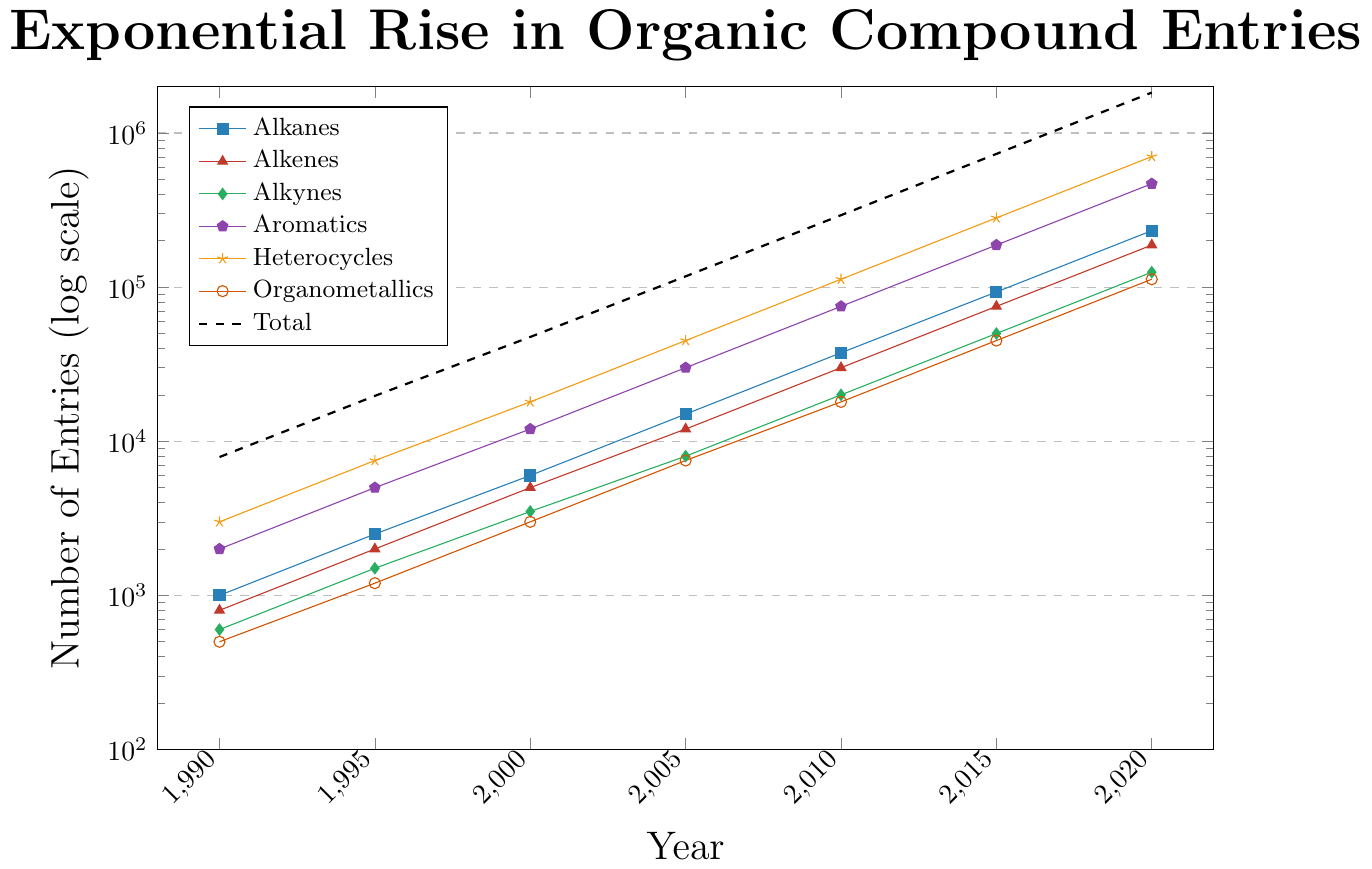What's the largest structural class of organic compounds recorded in 2020? First, look at the y-axis to see which compound class has the highest number in 2020. Among the alkanes, alkenes, alkynes, aromatics, heterocycles, and organometallics, identify the one with the maximum value. The dashed black line indicates the total, which isn't a structural class. In 2020, Heterocycles have the highest value.
Answer: Heterocycles How has the number of aromatic compounds changed from 1990 to 2020? To determine this, we need to look at the data points for aromatics in 1990 and 2020. In 1990, the number of aromatic entries is 2000. In 2020, it's 468750. Subtract the 1990 value from the 2020 value to find the difference: 468750 - 2000 = 466750.
Answer: Increased by 466750 Which structural class saw the fastest growth rate between 1990 and 2020? The growth rate can be estimated by comparing the ratio of the number of entries in 2020 to those in 1990 for each class. For alkanes: (232500/1000 = 232.5), alkenes: (187500/800 = 234.375), alkynes: (125000/600 = 208.33), aromatics: (468750/2000 = 234.375), heterocycles: (703125/3000 = 234.38), organometallics: (112500/500 = 225). Heterocycles have the highest ratio.
Answer: Heterocycles What is the trend in the total number of organic compound entries from 1990 to 2020? By observing the dashed black line that represents the total number of entries, it is clear that the entries increase exponentially from 1990 to 2020.
Answer: Exponential increase Which year saw the largest increase in the number of alkene entries compared to the previous recorded year? We need to calculate the difference in alkene entries between each adjacent pair of years. The differences are: 1995-1990: 2000-800 = 1200, 2000-1995: 5000-2000 = 3000, 2005-2000: 12000-5000 = 7000, 2010-2005: 30000-12000 = 18000, 2015-2010: 75000-30000 = 45000, 2020-2015: 187500-75000 = 112500. The largest increase is from 2015 to 2020.
Answer: 2020 How does the number of organometallic entries in 2020 compare with the number of alkane entries in 2015? Looking at the organometallic data for 2020, we see 112500 entries. For alkanes in 2015, there are 93000 entries. 112500 for organometallics in 2020 is greater than 93000 for alkanes in 2015.
Answer: Organometallics in 2020 are more than alkanes in 2015 What is the proportional gain of alkynes from 1995 to 2000? The number of alkynes in 1995 is 1500. In 2000, it is 3500. Compute the proportional gain by using the formula: (3500 - 1500) / 1500. The gain is (2000 / 1500) = 1.33, which indicates a 133% increase.
Answer: 133% Which structural class's entries reached 50000 first, and in which year? We need to identify the class that first reached the 50000 entries mark. From the graph, alkynes reach 50000 in 2015, while heterocycles reach it in the same year but with a higher count. However, aromatics touch 50000 earlier in 2010.
Answer: Aromatics in 2010 By what factor did the total number of organic compounds increase from 1990 to 2020? The total number of entries in 1990 is 7900. In 2020, it is 1829375. Compute the factor by dividing the 2020 value by the 1990 value: 1829375 / 7900 ≠ 231.10.
Answer: By about 231-fold Which two structural classes have nearly similar growth patterns over the years? The visual patterns of entries for alkanes and alkenes appear to be quite similar over the years, as their curves are very close together and exhibit similar exponential growth.
Answer: Alkanes and Alkenes 